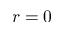<formula> <loc_0><loc_0><loc_500><loc_500>r = 0</formula> 